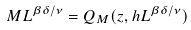Convert formula to latex. <formula><loc_0><loc_0><loc_500><loc_500>M L ^ { \beta \delta / \nu } = Q _ { M } ( z , h L ^ { \beta \delta / \nu } )</formula> 